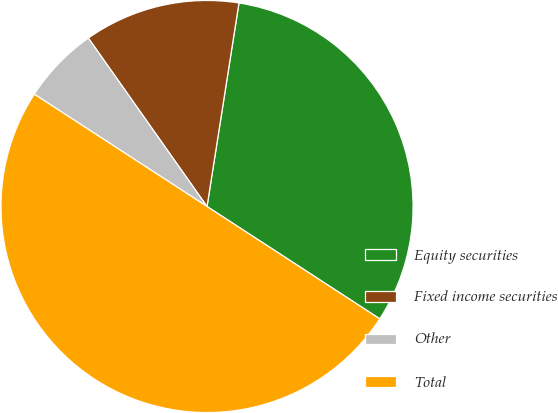<chart> <loc_0><loc_0><loc_500><loc_500><pie_chart><fcel>Equity securities<fcel>Fixed income securities<fcel>Other<fcel>Total<nl><fcel>31.7%<fcel>12.25%<fcel>6.05%<fcel>50.0%<nl></chart> 